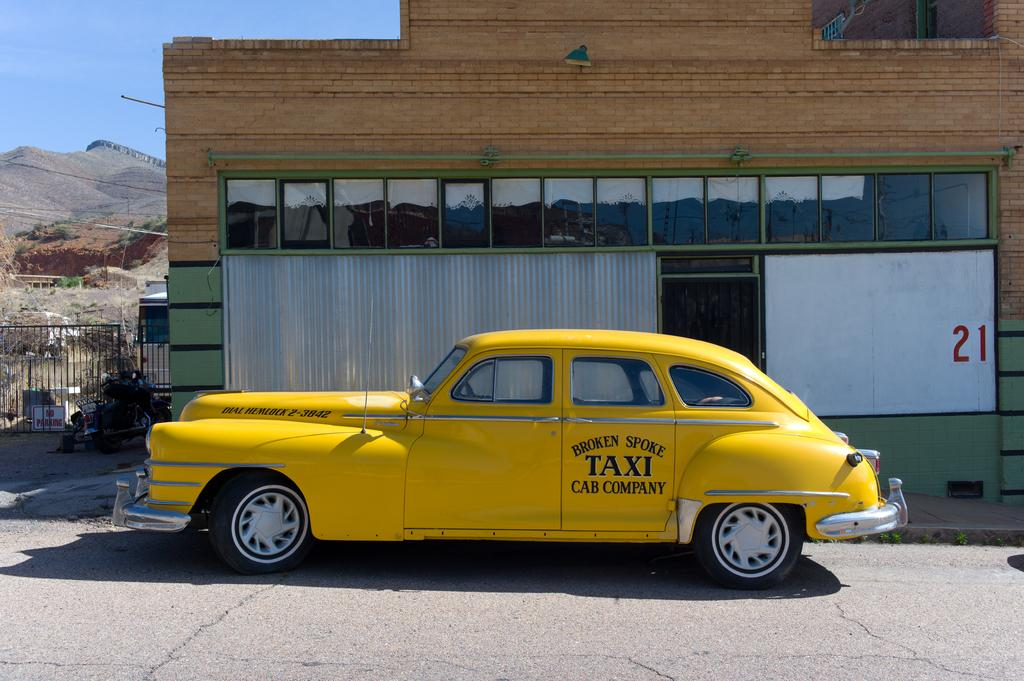<image>
Give a short and clear explanation of the subsequent image. An old yellow taxi cab with Broken Spoke Taxi Company on it. 